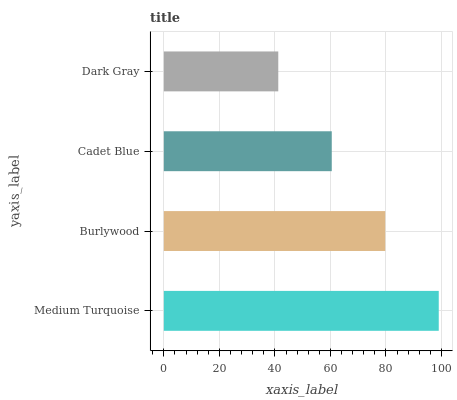Is Dark Gray the minimum?
Answer yes or no. Yes. Is Medium Turquoise the maximum?
Answer yes or no. Yes. Is Burlywood the minimum?
Answer yes or no. No. Is Burlywood the maximum?
Answer yes or no. No. Is Medium Turquoise greater than Burlywood?
Answer yes or no. Yes. Is Burlywood less than Medium Turquoise?
Answer yes or no. Yes. Is Burlywood greater than Medium Turquoise?
Answer yes or no. No. Is Medium Turquoise less than Burlywood?
Answer yes or no. No. Is Burlywood the high median?
Answer yes or no. Yes. Is Cadet Blue the low median?
Answer yes or no. Yes. Is Dark Gray the high median?
Answer yes or no. No. Is Burlywood the low median?
Answer yes or no. No. 